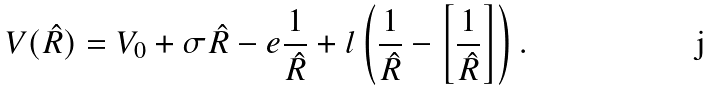<formula> <loc_0><loc_0><loc_500><loc_500>V ( \hat { R } ) = V _ { 0 } + \sigma \hat { R } - e \frac { 1 } { \hat { R } } + l \left ( \frac { 1 } { \hat { R } } - \left [ \frac { 1 } { \hat { R } } \right ] \right ) .</formula> 